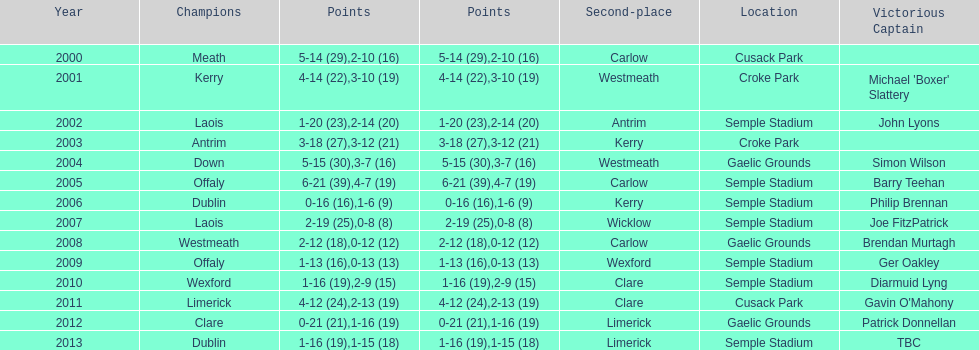Which team was the first to win with a team captain? Kerry. 